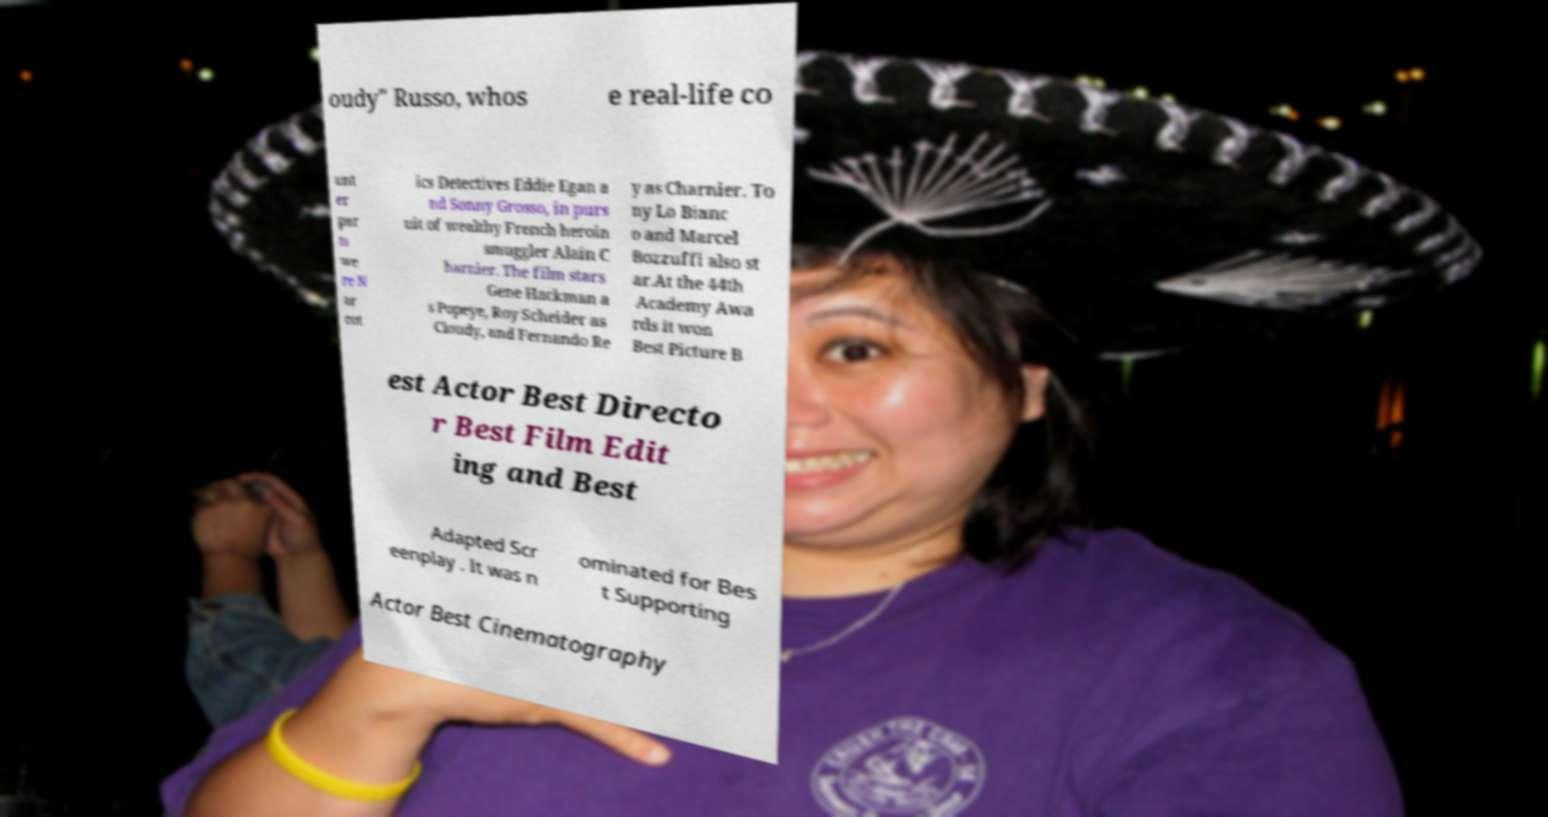Please read and relay the text visible in this image. What does it say? oudy" Russo, whos e real-life co unt er par ts we re N ar cot ics Detectives Eddie Egan a nd Sonny Grosso, in purs uit of wealthy French heroin smuggler Alain C harnier. The film stars Gene Hackman a s Popeye, Roy Scheider as Cloudy, and Fernando Re y as Charnier. To ny Lo Bianc o and Marcel Bozzuffi also st ar.At the 44th Academy Awa rds it won Best Picture B est Actor Best Directo r Best Film Edit ing and Best Adapted Scr eenplay . It was n ominated for Bes t Supporting Actor Best Cinematography 